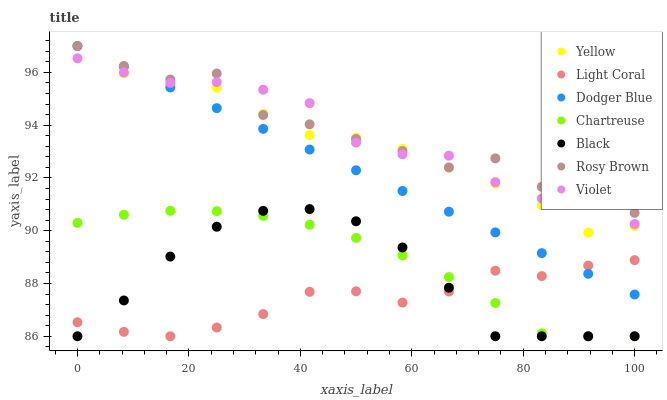Does Light Coral have the minimum area under the curve?
Answer yes or no. Yes. Does Rosy Brown have the maximum area under the curve?
Answer yes or no. Yes. Does Yellow have the minimum area under the curve?
Answer yes or no. No. Does Yellow have the maximum area under the curve?
Answer yes or no. No. Is Dodger Blue the smoothest?
Answer yes or no. Yes. Is Rosy Brown the roughest?
Answer yes or no. Yes. Is Yellow the smoothest?
Answer yes or no. No. Is Yellow the roughest?
Answer yes or no. No. Does Light Coral have the lowest value?
Answer yes or no. Yes. Does Yellow have the lowest value?
Answer yes or no. No. Does Dodger Blue have the highest value?
Answer yes or no. Yes. Does Light Coral have the highest value?
Answer yes or no. No. Is Light Coral less than Yellow?
Answer yes or no. Yes. Is Yellow greater than Light Coral?
Answer yes or no. Yes. Does Dodger Blue intersect Rosy Brown?
Answer yes or no. Yes. Is Dodger Blue less than Rosy Brown?
Answer yes or no. No. Is Dodger Blue greater than Rosy Brown?
Answer yes or no. No. Does Light Coral intersect Yellow?
Answer yes or no. No. 